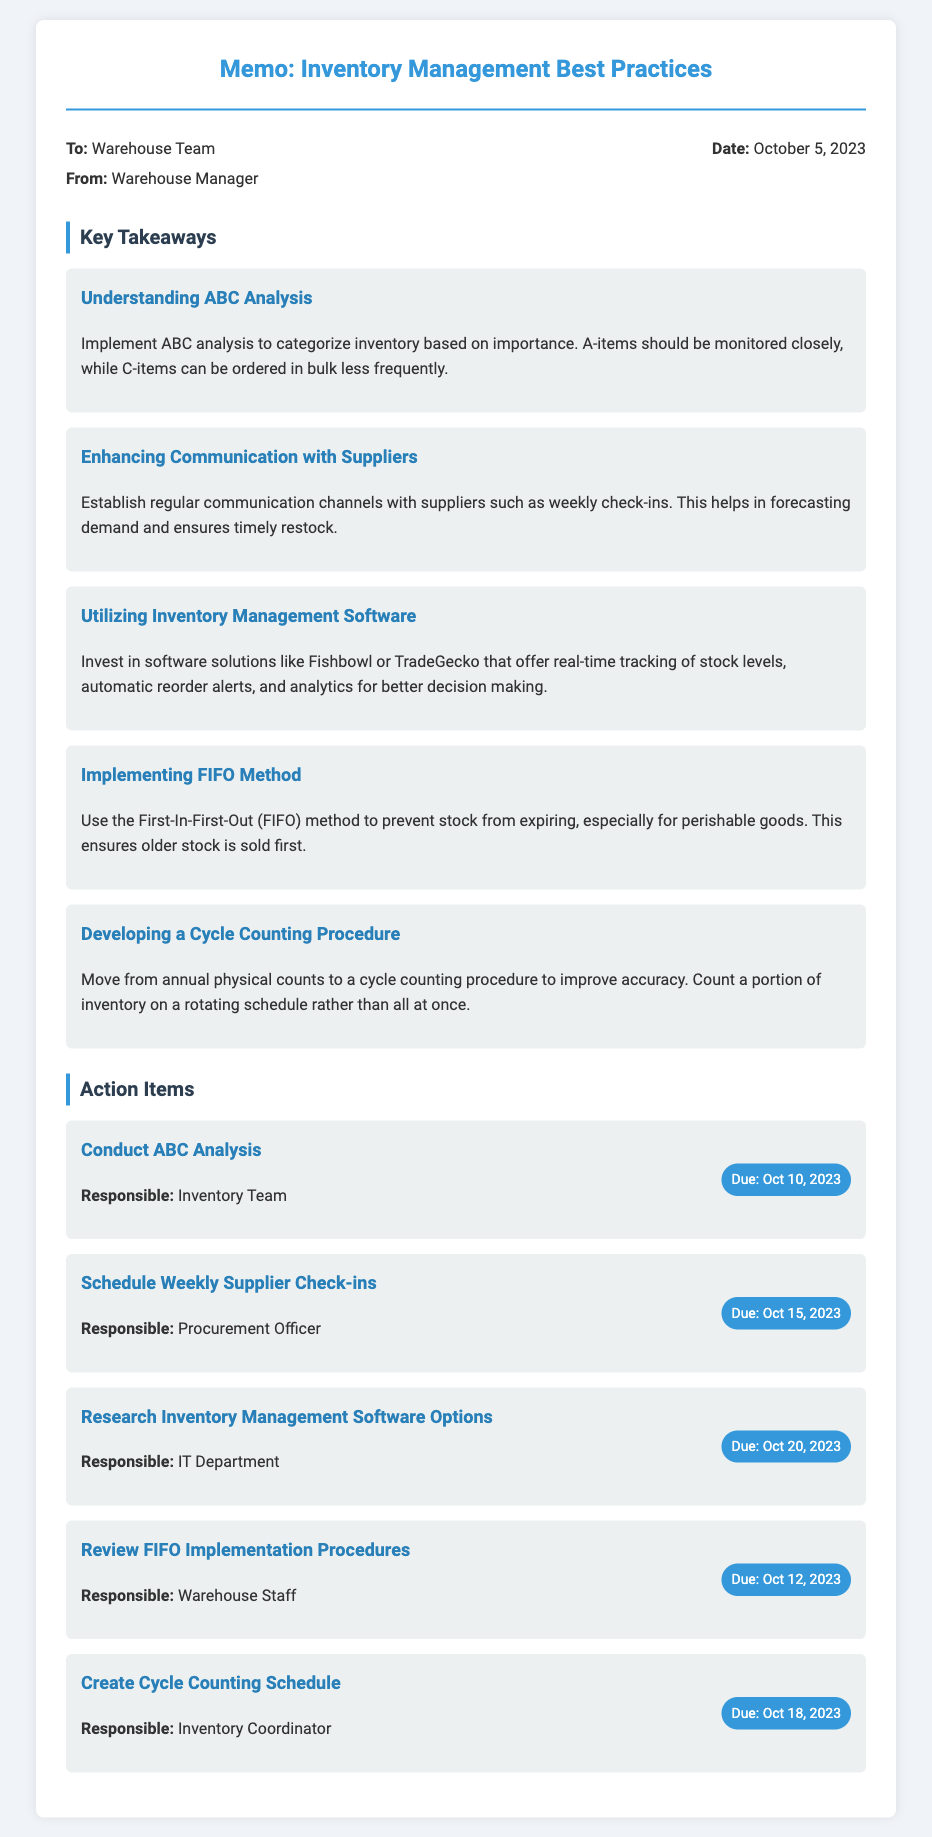What is the title of the memo? The title of the memo is specified at the top of the document.
Answer: Inventory Management Best Practices Who is the memo addressed to? The recipient of the memo is noted in the document details.
Answer: Warehouse Team What is the date of the memo? The date is explicitly mentioned in the memo details.
Answer: October 5, 2023 How many key takeaways are listed? The number of key takeaways can be counted from the sections of the document.
Answer: Five What method is recommended to prevent stock from expiring? This information is described in a takeaway section regarding inventory methods.
Answer: FIFO method Who is responsible for conducting the ABC analysis? The responsible party for this action item is indicated in the action items section.
Answer: Inventory Team What is the due date for scheduling weekly supplier check-ins? The deadline for this action item is provided in the respective action item details.
Answer: October 15, 2023 What is one of the inventory management software options mentioned? The document lists specific software solutions as part of the recommendations.
Answer: Fishbowl What does FIFO stand for? The context of the FIFO method is explained in the key takeaways.
Answer: First-In-First-Out 